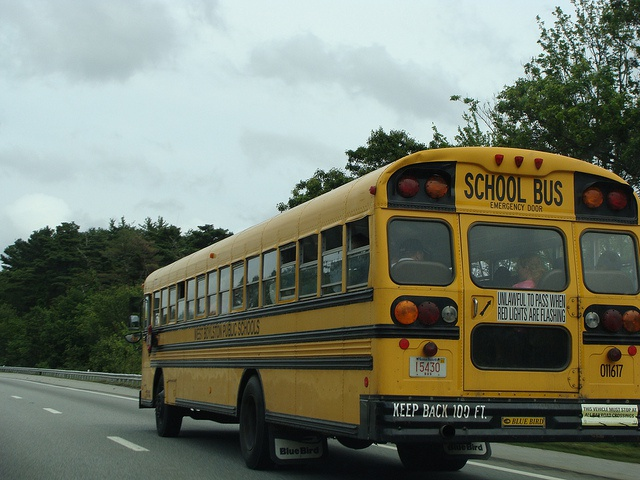Describe the objects in this image and their specific colors. I can see bus in lightblue, black, olive, and gray tones, people in lightblue, gray, black, and brown tones, people in lightblue, black, and gray tones, people in gray, darkgray, teal, and lightblue tones, and people in lightblue, black, and purple tones in this image. 